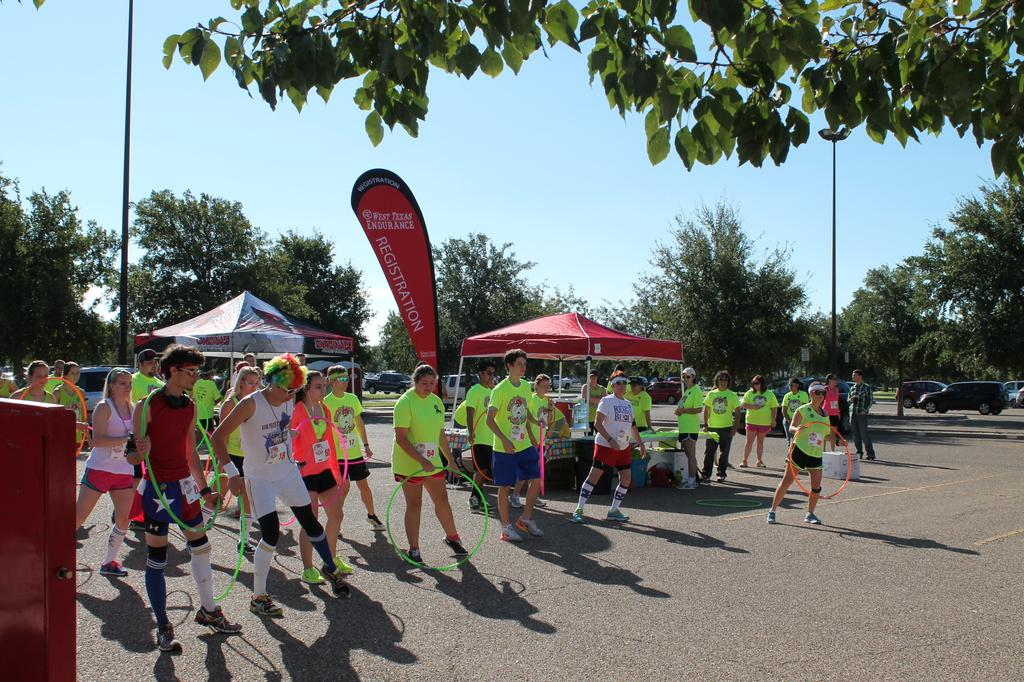What are the people in the image doing? The people in the image are standing and holding rings. What type of temporary shelters can be seen in the image? There are tents in the image. What structures are present in the image that might be used for support or stability? There are poles in the image. What can be seen in the background of the image? There are trees and sky visible in the background of the image. What type of transportation is present in the image? There are vehicles in the image. How many brothers are playing in the hole in the image? There is no hole or brothers present in the image. What type of business is being conducted in the image? There is no business activity depicted in the image. 